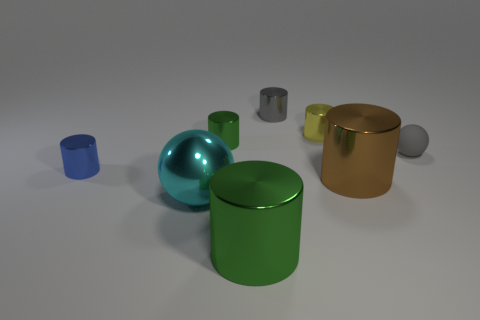Subtract all green cylinders. How many cylinders are left? 4 Subtract all yellow metal cylinders. How many cylinders are left? 5 Subtract all brown cylinders. Subtract all blue spheres. How many cylinders are left? 5 Add 1 large brown metal balls. How many objects exist? 9 Subtract all cylinders. How many objects are left? 2 Subtract 0 red cubes. How many objects are left? 8 Subtract all tiny cyan blocks. Subtract all tiny gray shiny cylinders. How many objects are left? 7 Add 6 small gray rubber objects. How many small gray rubber objects are left? 7 Add 2 green spheres. How many green spheres exist? 2 